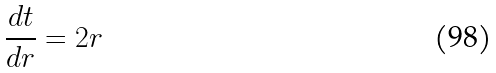Convert formula to latex. <formula><loc_0><loc_0><loc_500><loc_500>\frac { d t } { d r } = 2 r</formula> 